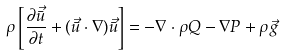<formula> <loc_0><loc_0><loc_500><loc_500>\rho \left [ \frac { \partial \vec { \bar { u } } } { \partial t } + ( \vec { \bar { u } } \cdot \nabla ) \vec { \bar { u } } \right ] = - \nabla \cdot \rho Q - \nabla P + \rho \vec { g }</formula> 